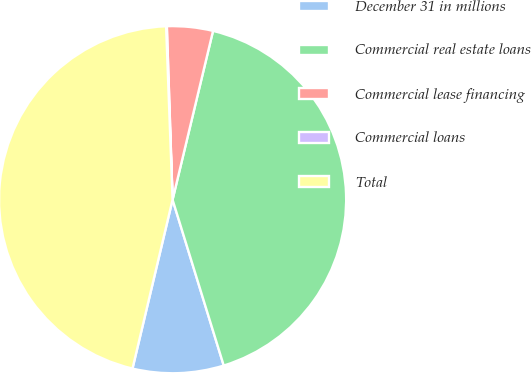Convert chart to OTSL. <chart><loc_0><loc_0><loc_500><loc_500><pie_chart><fcel>December 31 in millions<fcel>Commercial real estate loans<fcel>Commercial lease financing<fcel>Commercial loans<fcel>Total<nl><fcel>8.47%<fcel>41.49%<fcel>4.27%<fcel>0.07%<fcel>45.69%<nl></chart> 